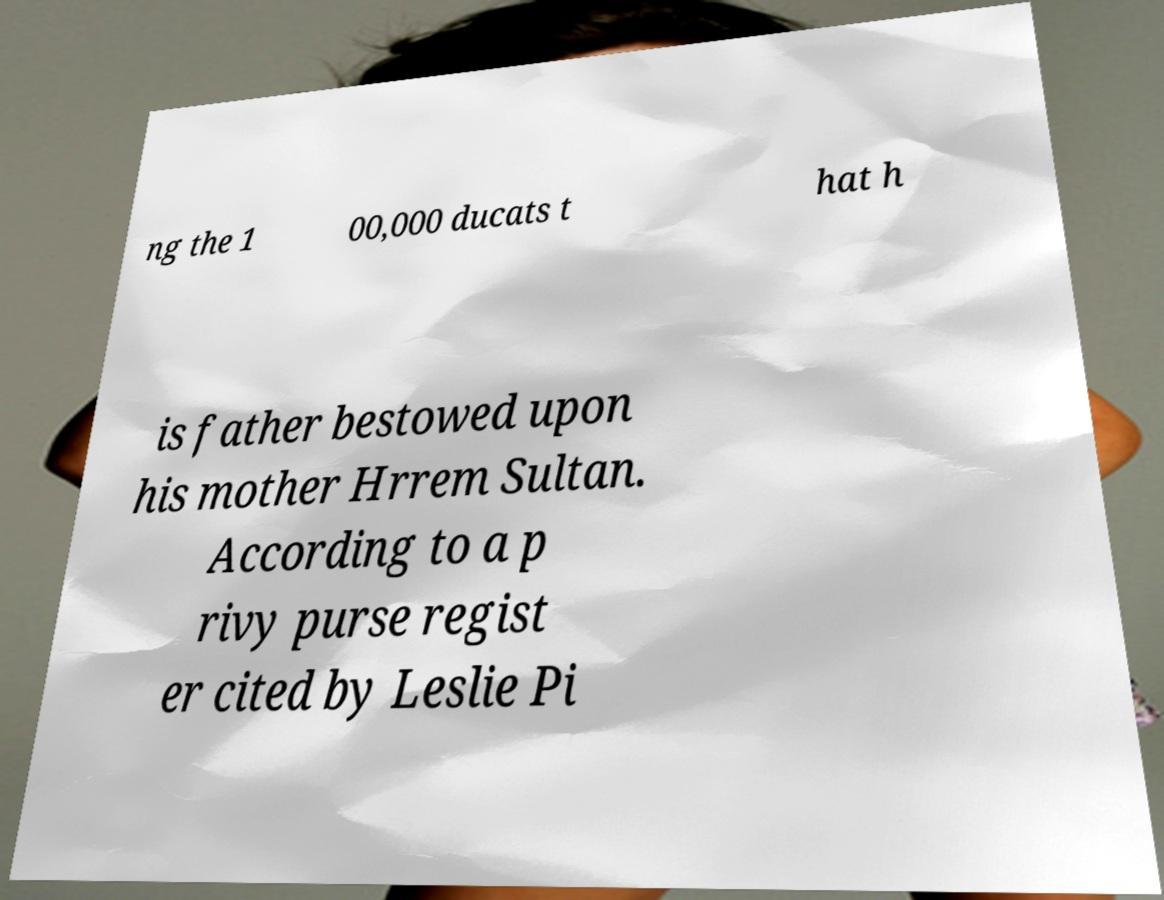Could you assist in decoding the text presented in this image and type it out clearly? ng the 1 00,000 ducats t hat h is father bestowed upon his mother Hrrem Sultan. According to a p rivy purse regist er cited by Leslie Pi 